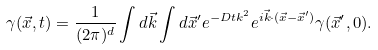Convert formula to latex. <formula><loc_0><loc_0><loc_500><loc_500>\gamma ( \vec { x } , t ) = \frac { 1 } { ( 2 \pi ) ^ { d } } \int d \vec { k } \int d \vec { x } ^ { \prime } e ^ { - D t k ^ { 2 } } e ^ { i \vec { k } \cdot ( \vec { x } - \vec { x } ^ { \prime } ) } \gamma ( \vec { x } ^ { \prime } , 0 ) .</formula> 